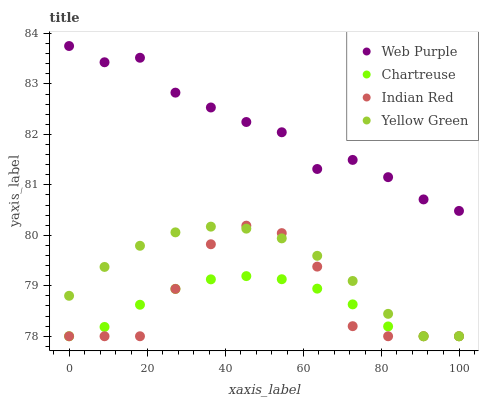Does Chartreuse have the minimum area under the curve?
Answer yes or no. Yes. Does Web Purple have the maximum area under the curve?
Answer yes or no. Yes. Does Indian Red have the minimum area under the curve?
Answer yes or no. No. Does Indian Red have the maximum area under the curve?
Answer yes or no. No. Is Chartreuse the smoothest?
Answer yes or no. Yes. Is Indian Red the roughest?
Answer yes or no. Yes. Is Indian Red the smoothest?
Answer yes or no. No. Is Chartreuse the roughest?
Answer yes or no. No. Does Chartreuse have the lowest value?
Answer yes or no. Yes. Does Web Purple have the highest value?
Answer yes or no. Yes. Does Indian Red have the highest value?
Answer yes or no. No. Is Indian Red less than Web Purple?
Answer yes or no. Yes. Is Web Purple greater than Chartreuse?
Answer yes or no. Yes. Does Chartreuse intersect Yellow Green?
Answer yes or no. Yes. Is Chartreuse less than Yellow Green?
Answer yes or no. No. Is Chartreuse greater than Yellow Green?
Answer yes or no. No. Does Indian Red intersect Web Purple?
Answer yes or no. No. 